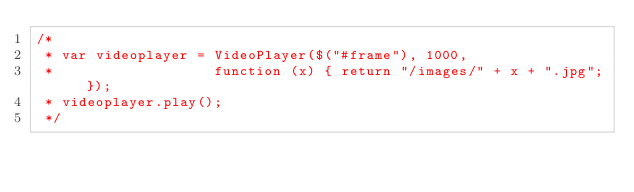<code> <loc_0><loc_0><loc_500><loc_500><_JavaScript_>/*
 * var videoplayer = VideoPlayer($("#frame"), 1000,
 *                   function (x) { return "/images/" + x + ".jpg"; });
 * videoplayer.play();
 */</code> 